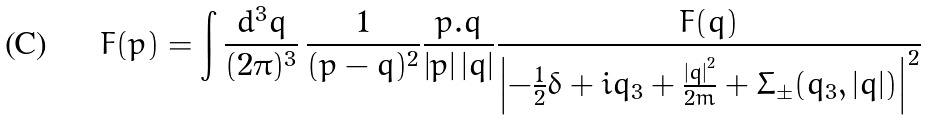Convert formula to latex. <formula><loc_0><loc_0><loc_500><loc_500>F ( p ) = \int \frac { d ^ { 3 } q } { ( 2 \pi ) ^ { 3 } } \, \frac { 1 } { ( p - q ) ^ { 2 } } \frac { p . q } { \left | { p } \right | \left | { q } \right | } \frac { F ( q ) } { \left | - \frac { 1 } { 2 } \delta + i q _ { 3 } + \frac { \left | { q } \right | ^ { 2 } } { 2 m } + \Sigma _ { \pm } ( q _ { 3 } , \left | { q } \right | ) \right | ^ { 2 } }</formula> 